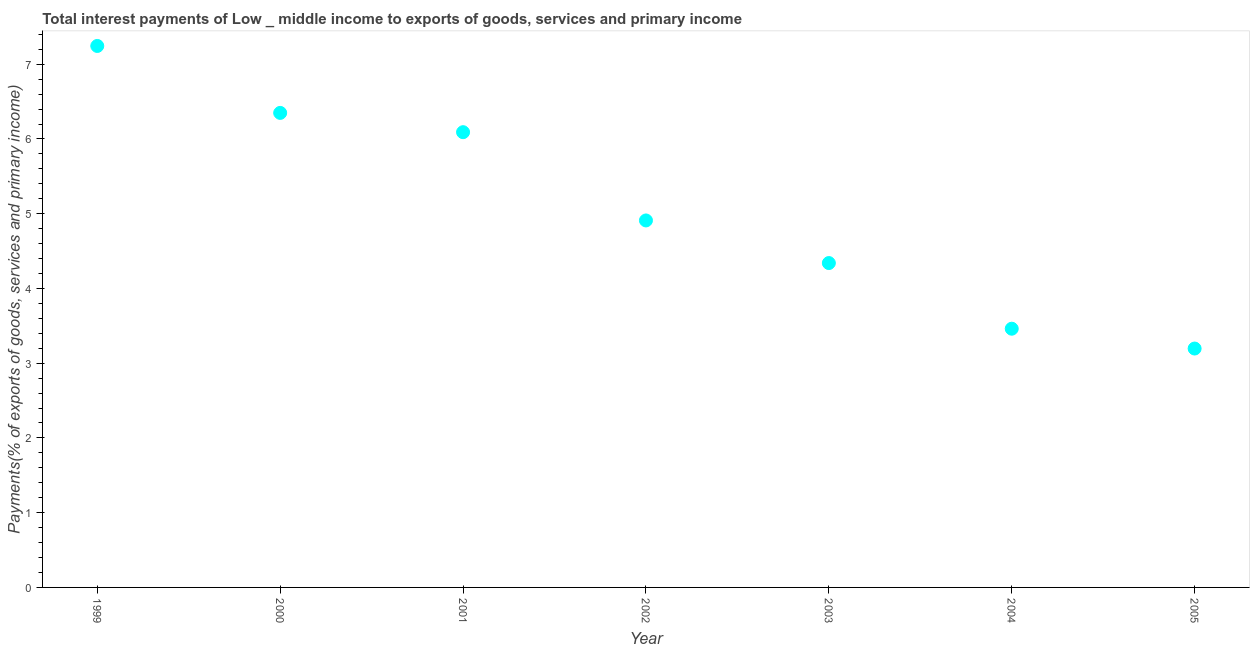What is the total interest payments on external debt in 2002?
Ensure brevity in your answer.  4.91. Across all years, what is the maximum total interest payments on external debt?
Make the answer very short. 7.24. Across all years, what is the minimum total interest payments on external debt?
Ensure brevity in your answer.  3.2. In which year was the total interest payments on external debt maximum?
Your answer should be compact. 1999. What is the sum of the total interest payments on external debt?
Provide a succinct answer. 35.59. What is the difference between the total interest payments on external debt in 2002 and 2004?
Keep it short and to the point. 1.45. What is the average total interest payments on external debt per year?
Make the answer very short. 5.08. What is the median total interest payments on external debt?
Offer a very short reply. 4.91. Do a majority of the years between 2000 and 1999 (inclusive) have total interest payments on external debt greater than 0.8 %?
Your answer should be compact. No. What is the ratio of the total interest payments on external debt in 2000 to that in 2005?
Provide a succinct answer. 1.99. What is the difference between the highest and the second highest total interest payments on external debt?
Provide a succinct answer. 0.9. What is the difference between the highest and the lowest total interest payments on external debt?
Keep it short and to the point. 4.05. Does the total interest payments on external debt monotonically increase over the years?
Your response must be concise. No. How many dotlines are there?
Provide a short and direct response. 1. How many years are there in the graph?
Make the answer very short. 7. What is the difference between two consecutive major ticks on the Y-axis?
Make the answer very short. 1. Are the values on the major ticks of Y-axis written in scientific E-notation?
Offer a very short reply. No. What is the title of the graph?
Your answer should be compact. Total interest payments of Low _ middle income to exports of goods, services and primary income. What is the label or title of the X-axis?
Your answer should be very brief. Year. What is the label or title of the Y-axis?
Offer a very short reply. Payments(% of exports of goods, services and primary income). What is the Payments(% of exports of goods, services and primary income) in 1999?
Your answer should be compact. 7.24. What is the Payments(% of exports of goods, services and primary income) in 2000?
Keep it short and to the point. 6.35. What is the Payments(% of exports of goods, services and primary income) in 2001?
Offer a very short reply. 6.09. What is the Payments(% of exports of goods, services and primary income) in 2002?
Provide a succinct answer. 4.91. What is the Payments(% of exports of goods, services and primary income) in 2003?
Ensure brevity in your answer.  4.34. What is the Payments(% of exports of goods, services and primary income) in 2004?
Offer a terse response. 3.46. What is the Payments(% of exports of goods, services and primary income) in 2005?
Your answer should be compact. 3.2. What is the difference between the Payments(% of exports of goods, services and primary income) in 1999 and 2000?
Make the answer very short. 0.9. What is the difference between the Payments(% of exports of goods, services and primary income) in 1999 and 2001?
Your answer should be compact. 1.15. What is the difference between the Payments(% of exports of goods, services and primary income) in 1999 and 2002?
Provide a short and direct response. 2.33. What is the difference between the Payments(% of exports of goods, services and primary income) in 1999 and 2003?
Offer a terse response. 2.9. What is the difference between the Payments(% of exports of goods, services and primary income) in 1999 and 2004?
Provide a succinct answer. 3.78. What is the difference between the Payments(% of exports of goods, services and primary income) in 1999 and 2005?
Give a very brief answer. 4.05. What is the difference between the Payments(% of exports of goods, services and primary income) in 2000 and 2001?
Provide a succinct answer. 0.26. What is the difference between the Payments(% of exports of goods, services and primary income) in 2000 and 2002?
Give a very brief answer. 1.44. What is the difference between the Payments(% of exports of goods, services and primary income) in 2000 and 2003?
Offer a very short reply. 2.01. What is the difference between the Payments(% of exports of goods, services and primary income) in 2000 and 2004?
Keep it short and to the point. 2.89. What is the difference between the Payments(% of exports of goods, services and primary income) in 2000 and 2005?
Offer a very short reply. 3.15. What is the difference between the Payments(% of exports of goods, services and primary income) in 2001 and 2002?
Provide a succinct answer. 1.18. What is the difference between the Payments(% of exports of goods, services and primary income) in 2001 and 2003?
Keep it short and to the point. 1.75. What is the difference between the Payments(% of exports of goods, services and primary income) in 2001 and 2004?
Ensure brevity in your answer.  2.63. What is the difference between the Payments(% of exports of goods, services and primary income) in 2001 and 2005?
Make the answer very short. 2.89. What is the difference between the Payments(% of exports of goods, services and primary income) in 2002 and 2003?
Provide a succinct answer. 0.57. What is the difference between the Payments(% of exports of goods, services and primary income) in 2002 and 2004?
Provide a short and direct response. 1.45. What is the difference between the Payments(% of exports of goods, services and primary income) in 2002 and 2005?
Give a very brief answer. 1.71. What is the difference between the Payments(% of exports of goods, services and primary income) in 2003 and 2004?
Offer a very short reply. 0.88. What is the difference between the Payments(% of exports of goods, services and primary income) in 2003 and 2005?
Give a very brief answer. 1.14. What is the difference between the Payments(% of exports of goods, services and primary income) in 2004 and 2005?
Keep it short and to the point. 0.27. What is the ratio of the Payments(% of exports of goods, services and primary income) in 1999 to that in 2000?
Provide a succinct answer. 1.14. What is the ratio of the Payments(% of exports of goods, services and primary income) in 1999 to that in 2001?
Provide a short and direct response. 1.19. What is the ratio of the Payments(% of exports of goods, services and primary income) in 1999 to that in 2002?
Make the answer very short. 1.48. What is the ratio of the Payments(% of exports of goods, services and primary income) in 1999 to that in 2003?
Keep it short and to the point. 1.67. What is the ratio of the Payments(% of exports of goods, services and primary income) in 1999 to that in 2004?
Make the answer very short. 2.09. What is the ratio of the Payments(% of exports of goods, services and primary income) in 1999 to that in 2005?
Your answer should be compact. 2.27. What is the ratio of the Payments(% of exports of goods, services and primary income) in 2000 to that in 2001?
Provide a short and direct response. 1.04. What is the ratio of the Payments(% of exports of goods, services and primary income) in 2000 to that in 2002?
Ensure brevity in your answer.  1.29. What is the ratio of the Payments(% of exports of goods, services and primary income) in 2000 to that in 2003?
Give a very brief answer. 1.46. What is the ratio of the Payments(% of exports of goods, services and primary income) in 2000 to that in 2004?
Your answer should be compact. 1.83. What is the ratio of the Payments(% of exports of goods, services and primary income) in 2000 to that in 2005?
Give a very brief answer. 1.99. What is the ratio of the Payments(% of exports of goods, services and primary income) in 2001 to that in 2002?
Ensure brevity in your answer.  1.24. What is the ratio of the Payments(% of exports of goods, services and primary income) in 2001 to that in 2003?
Keep it short and to the point. 1.4. What is the ratio of the Payments(% of exports of goods, services and primary income) in 2001 to that in 2004?
Your answer should be very brief. 1.76. What is the ratio of the Payments(% of exports of goods, services and primary income) in 2001 to that in 2005?
Offer a terse response. 1.91. What is the ratio of the Payments(% of exports of goods, services and primary income) in 2002 to that in 2003?
Your answer should be very brief. 1.13. What is the ratio of the Payments(% of exports of goods, services and primary income) in 2002 to that in 2004?
Your response must be concise. 1.42. What is the ratio of the Payments(% of exports of goods, services and primary income) in 2002 to that in 2005?
Your answer should be compact. 1.54. What is the ratio of the Payments(% of exports of goods, services and primary income) in 2003 to that in 2004?
Make the answer very short. 1.25. What is the ratio of the Payments(% of exports of goods, services and primary income) in 2003 to that in 2005?
Keep it short and to the point. 1.36. What is the ratio of the Payments(% of exports of goods, services and primary income) in 2004 to that in 2005?
Your answer should be very brief. 1.08. 